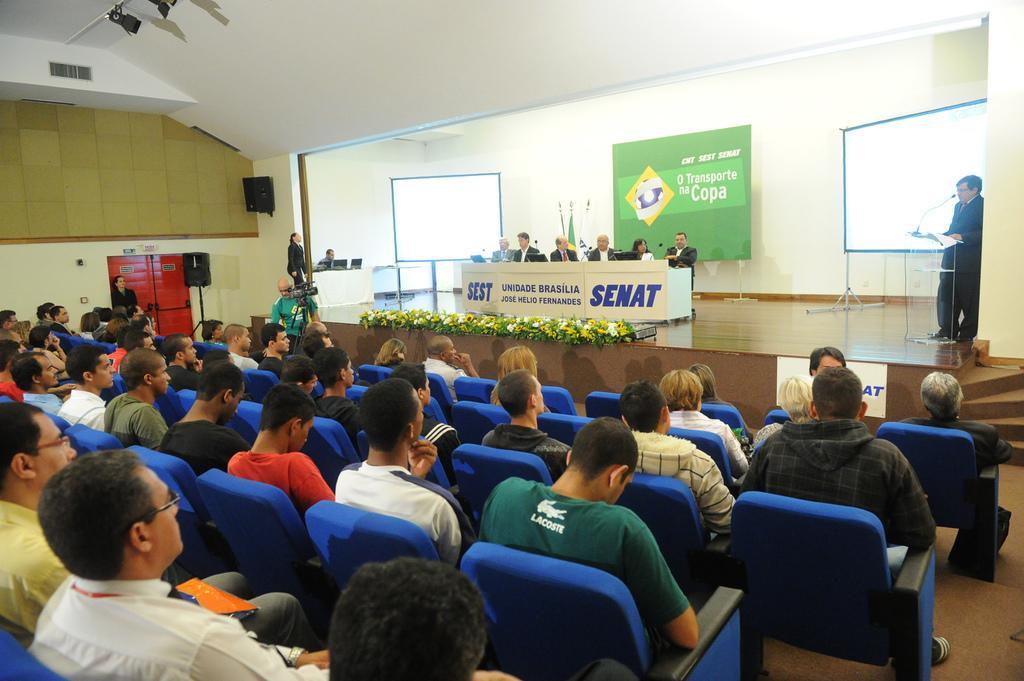How would you summarize this image in a sentence or two? In the left a group of people are sitting on the chairs. In the middle few people are sitting on the stage and in the right side a person is standing and talking in the microphone. 